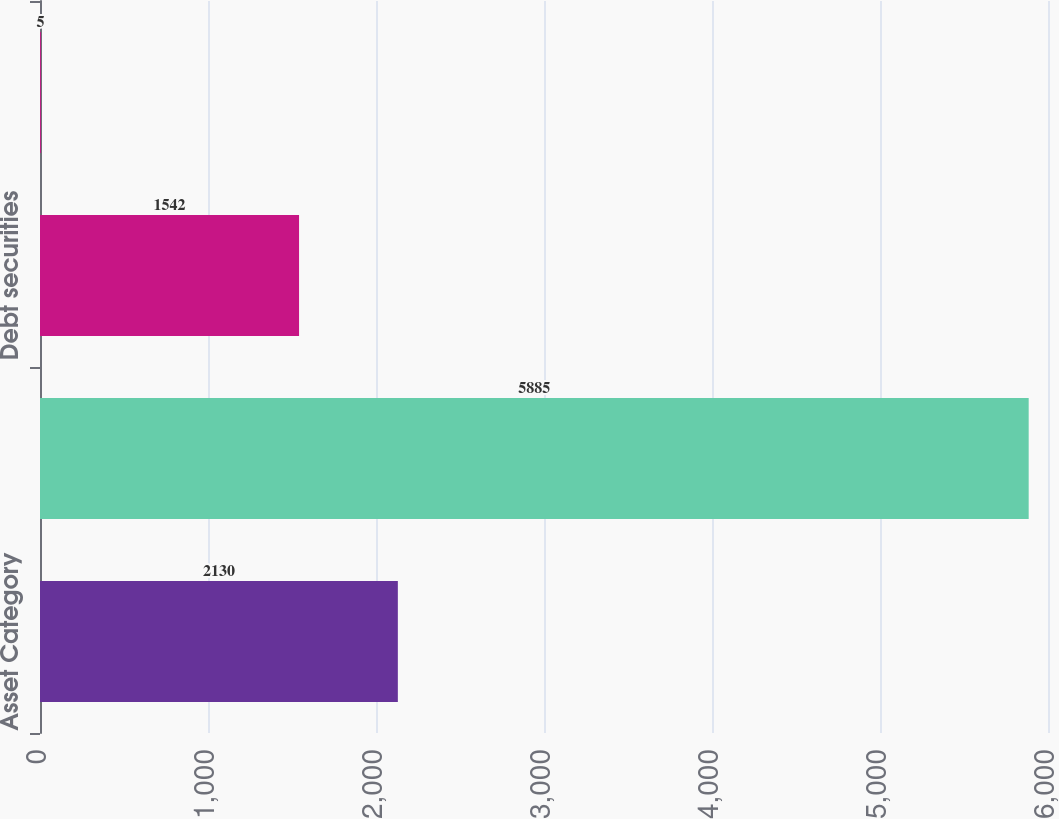<chart> <loc_0><loc_0><loc_500><loc_500><bar_chart><fcel>Asset Category<fcel>Equity securities<fcel>Debt securities<fcel>Other<nl><fcel>2130<fcel>5885<fcel>1542<fcel>5<nl></chart> 